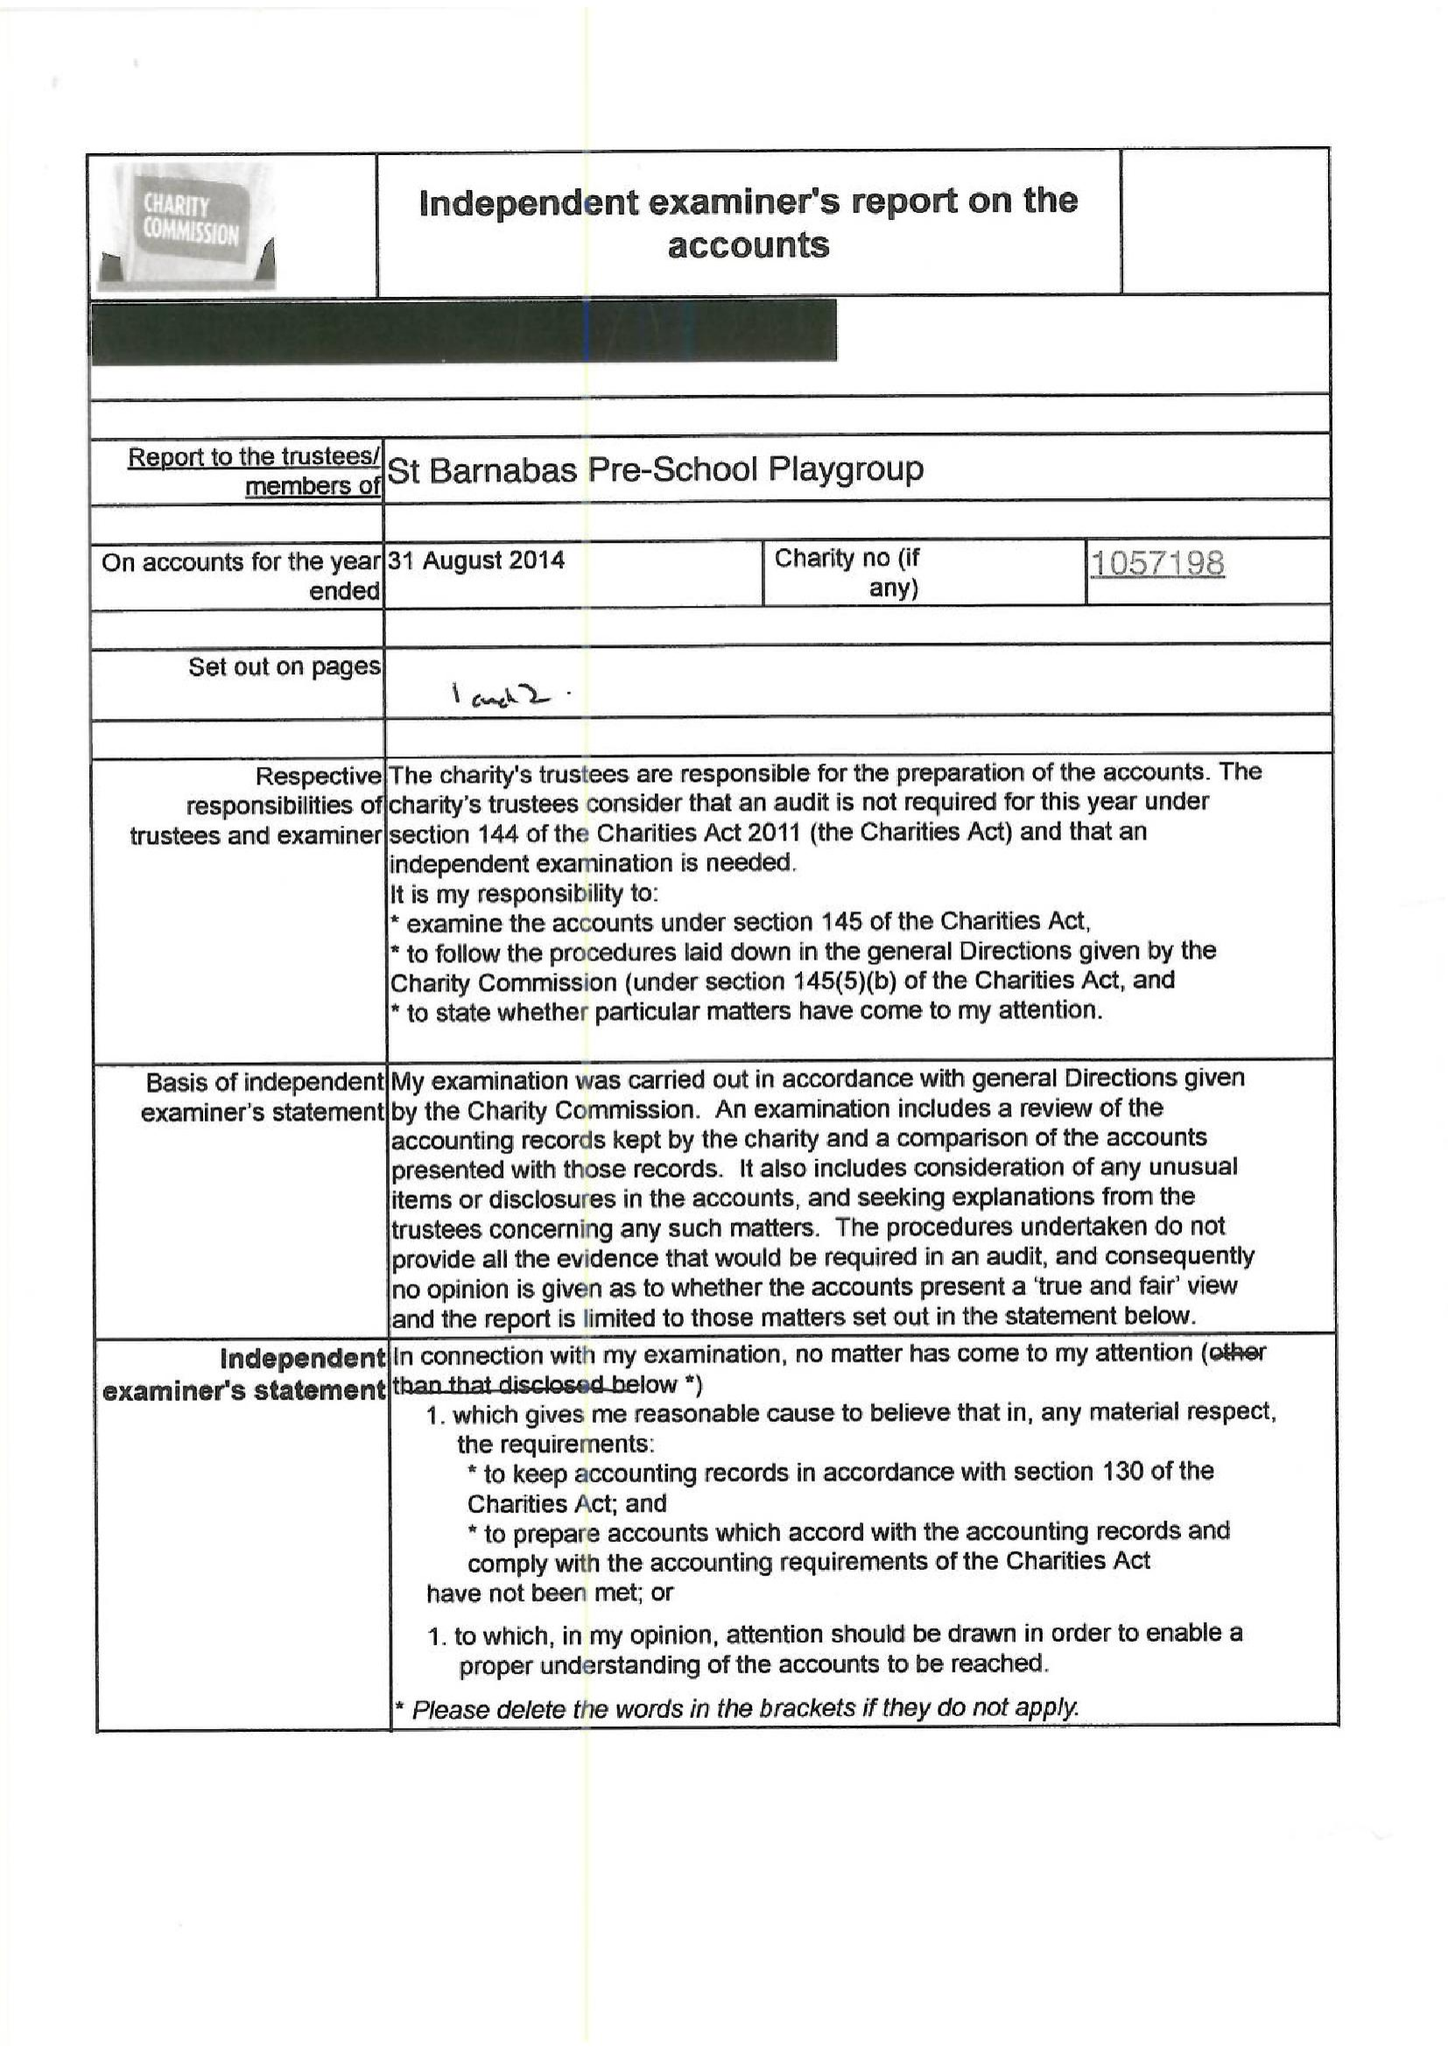What is the value for the address__post_town?
Answer the question using a single word or phrase. LONDON 